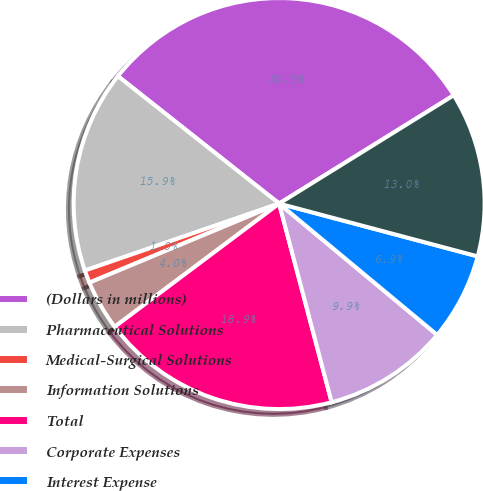Convert chart. <chart><loc_0><loc_0><loc_500><loc_500><pie_chart><fcel>(Dollars in millions)<fcel>Pharmaceutical Solutions<fcel>Medical-Surgical Solutions<fcel>Information Solutions<fcel>Total<fcel>Corporate Expenses<fcel>Interest Expense<fcel>Income from Continuing<nl><fcel>30.52%<fcel>15.93%<fcel>1.0%<fcel>3.95%<fcel>18.88%<fcel>9.85%<fcel>6.9%<fcel>12.97%<nl></chart> 